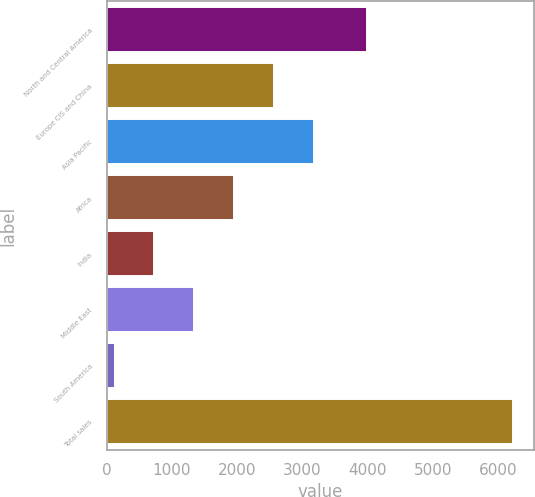<chart> <loc_0><loc_0><loc_500><loc_500><bar_chart><fcel>North and Central America<fcel>Europe CIS and China<fcel>Asia Pacific<fcel>Africa<fcel>India<fcel>Middle East<fcel>South America<fcel>Total sales<nl><fcel>3992<fcel>2563.6<fcel>3174.5<fcel>1952.7<fcel>730.9<fcel>1341.8<fcel>120<fcel>6229<nl></chart> 